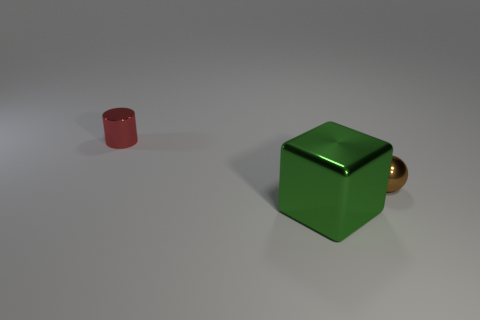Add 1 big cyan metal things. How many objects exist? 4 Subtract all cylinders. How many objects are left? 2 Add 1 large green metallic blocks. How many large green metallic blocks are left? 2 Add 3 metallic cylinders. How many metallic cylinders exist? 4 Subtract 0 purple balls. How many objects are left? 3 Subtract all cylinders. Subtract all small things. How many objects are left? 0 